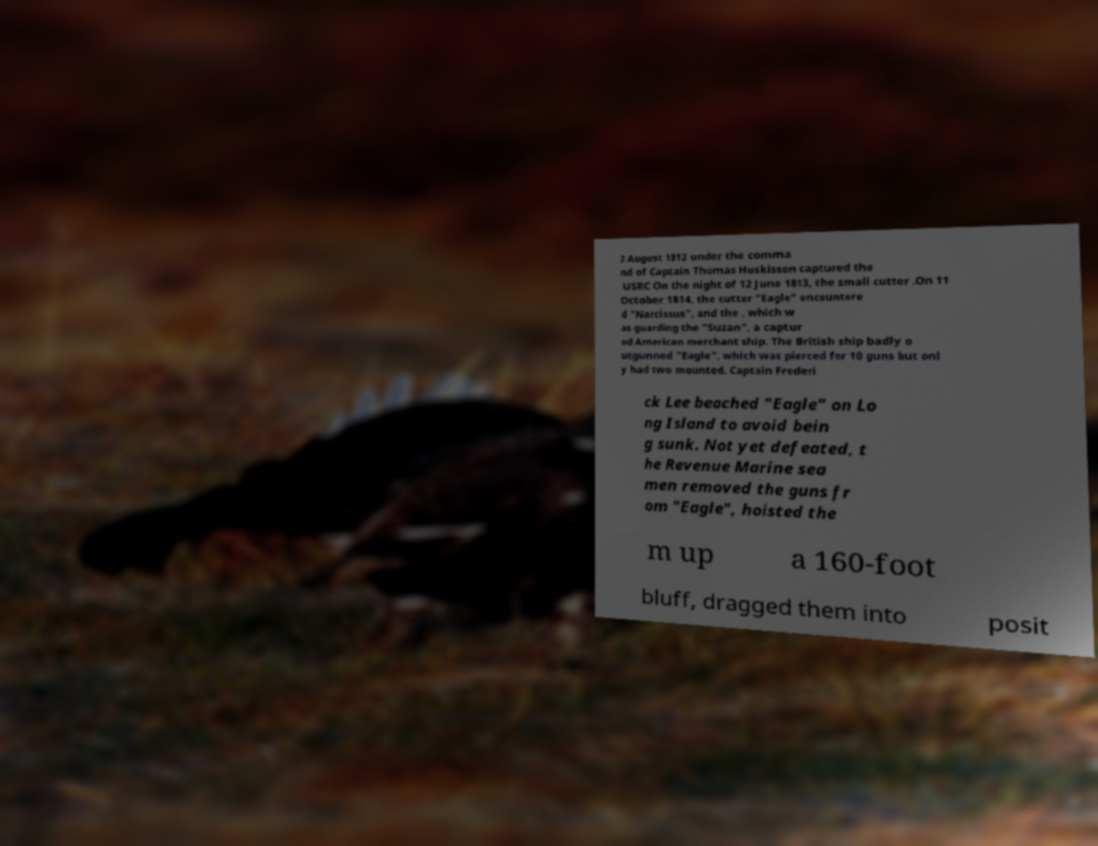Please read and relay the text visible in this image. What does it say? 2 August 1812 under the comma nd of Captain Thomas Huskisson captured the USRC On the night of 12 June 1813, the small cutter .On 11 October 1814, the cutter "Eagle" encountere d "Narcissus", and the , which w as guarding the "Suzan", a captur ed American merchant ship. The British ship badly o utgunned "Eagle", which was pierced for 10 guns but onl y had two mounted. Captain Frederi ck Lee beached "Eagle" on Lo ng Island to avoid bein g sunk. Not yet defeated, t he Revenue Marine sea men removed the guns fr om "Eagle", hoisted the m up a 160-foot bluff, dragged them into posit 